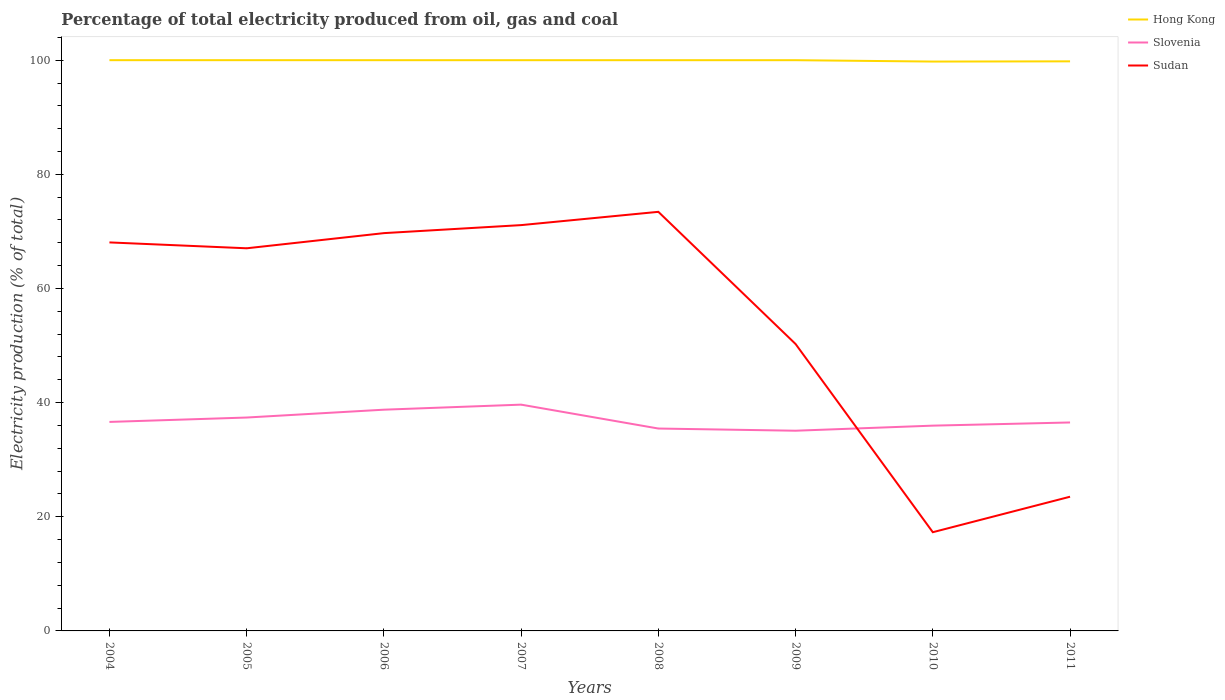Does the line corresponding to Slovenia intersect with the line corresponding to Sudan?
Give a very brief answer. Yes. Is the number of lines equal to the number of legend labels?
Make the answer very short. Yes. Across all years, what is the maximum electricity production in in Hong Kong?
Your response must be concise. 99.76. In which year was the electricity production in in Hong Kong maximum?
Keep it short and to the point. 2010. What is the total electricity production in in Slovenia in the graph?
Make the answer very short. -0.89. What is the difference between the highest and the second highest electricity production in in Sudan?
Offer a terse response. 56.13. How many lines are there?
Your response must be concise. 3. How many years are there in the graph?
Provide a succinct answer. 8. What is the difference between two consecutive major ticks on the Y-axis?
Your answer should be very brief. 20. Are the values on the major ticks of Y-axis written in scientific E-notation?
Make the answer very short. No. Does the graph contain any zero values?
Make the answer very short. No. Where does the legend appear in the graph?
Make the answer very short. Top right. How many legend labels are there?
Keep it short and to the point. 3. How are the legend labels stacked?
Keep it short and to the point. Vertical. What is the title of the graph?
Offer a terse response. Percentage of total electricity produced from oil, gas and coal. What is the label or title of the X-axis?
Give a very brief answer. Years. What is the label or title of the Y-axis?
Provide a succinct answer. Electricity production (% of total). What is the Electricity production (% of total) of Slovenia in 2004?
Keep it short and to the point. 36.62. What is the Electricity production (% of total) in Sudan in 2004?
Ensure brevity in your answer.  68.07. What is the Electricity production (% of total) of Slovenia in 2005?
Your answer should be compact. 37.39. What is the Electricity production (% of total) in Sudan in 2005?
Make the answer very short. 67.04. What is the Electricity production (% of total) of Hong Kong in 2006?
Your response must be concise. 100. What is the Electricity production (% of total) of Slovenia in 2006?
Provide a succinct answer. 38.76. What is the Electricity production (% of total) in Sudan in 2006?
Give a very brief answer. 69.7. What is the Electricity production (% of total) in Hong Kong in 2007?
Give a very brief answer. 100. What is the Electricity production (% of total) in Slovenia in 2007?
Keep it short and to the point. 39.65. What is the Electricity production (% of total) of Sudan in 2007?
Offer a very short reply. 71.1. What is the Electricity production (% of total) of Hong Kong in 2008?
Make the answer very short. 100. What is the Electricity production (% of total) of Slovenia in 2008?
Provide a short and direct response. 35.46. What is the Electricity production (% of total) in Sudan in 2008?
Offer a very short reply. 73.43. What is the Electricity production (% of total) in Hong Kong in 2009?
Provide a short and direct response. 100. What is the Electricity production (% of total) in Slovenia in 2009?
Offer a terse response. 35.08. What is the Electricity production (% of total) in Sudan in 2009?
Keep it short and to the point. 50.27. What is the Electricity production (% of total) in Hong Kong in 2010?
Your answer should be very brief. 99.76. What is the Electricity production (% of total) of Slovenia in 2010?
Offer a very short reply. 35.97. What is the Electricity production (% of total) in Sudan in 2010?
Provide a succinct answer. 17.3. What is the Electricity production (% of total) of Hong Kong in 2011?
Provide a short and direct response. 99.8. What is the Electricity production (% of total) of Slovenia in 2011?
Provide a short and direct response. 36.52. What is the Electricity production (% of total) of Sudan in 2011?
Offer a terse response. 23.51. Across all years, what is the maximum Electricity production (% of total) of Hong Kong?
Offer a very short reply. 100. Across all years, what is the maximum Electricity production (% of total) in Slovenia?
Your response must be concise. 39.65. Across all years, what is the maximum Electricity production (% of total) in Sudan?
Provide a short and direct response. 73.43. Across all years, what is the minimum Electricity production (% of total) of Hong Kong?
Give a very brief answer. 99.76. Across all years, what is the minimum Electricity production (% of total) in Slovenia?
Ensure brevity in your answer.  35.08. Across all years, what is the minimum Electricity production (% of total) in Sudan?
Your response must be concise. 17.3. What is the total Electricity production (% of total) of Hong Kong in the graph?
Offer a very short reply. 799.54. What is the total Electricity production (% of total) in Slovenia in the graph?
Make the answer very short. 295.44. What is the total Electricity production (% of total) of Sudan in the graph?
Offer a very short reply. 440.42. What is the difference between the Electricity production (% of total) of Hong Kong in 2004 and that in 2005?
Your answer should be very brief. 0. What is the difference between the Electricity production (% of total) of Slovenia in 2004 and that in 2005?
Provide a succinct answer. -0.77. What is the difference between the Electricity production (% of total) in Sudan in 2004 and that in 2005?
Provide a short and direct response. 1.03. What is the difference between the Electricity production (% of total) of Hong Kong in 2004 and that in 2006?
Ensure brevity in your answer.  0. What is the difference between the Electricity production (% of total) of Slovenia in 2004 and that in 2006?
Offer a terse response. -2.14. What is the difference between the Electricity production (% of total) of Sudan in 2004 and that in 2006?
Your answer should be very brief. -1.63. What is the difference between the Electricity production (% of total) of Hong Kong in 2004 and that in 2007?
Provide a short and direct response. 0. What is the difference between the Electricity production (% of total) in Slovenia in 2004 and that in 2007?
Your response must be concise. -3.03. What is the difference between the Electricity production (% of total) in Sudan in 2004 and that in 2007?
Your response must be concise. -3.03. What is the difference between the Electricity production (% of total) in Hong Kong in 2004 and that in 2008?
Your answer should be compact. 0. What is the difference between the Electricity production (% of total) in Slovenia in 2004 and that in 2008?
Your answer should be compact. 1.16. What is the difference between the Electricity production (% of total) in Sudan in 2004 and that in 2008?
Provide a succinct answer. -5.36. What is the difference between the Electricity production (% of total) in Hong Kong in 2004 and that in 2009?
Make the answer very short. 0. What is the difference between the Electricity production (% of total) of Slovenia in 2004 and that in 2009?
Keep it short and to the point. 1.54. What is the difference between the Electricity production (% of total) of Sudan in 2004 and that in 2009?
Keep it short and to the point. 17.8. What is the difference between the Electricity production (% of total) in Hong Kong in 2004 and that in 2010?
Your answer should be compact. 0.24. What is the difference between the Electricity production (% of total) in Slovenia in 2004 and that in 2010?
Your answer should be compact. 0.65. What is the difference between the Electricity production (% of total) of Sudan in 2004 and that in 2010?
Your answer should be compact. 50.77. What is the difference between the Electricity production (% of total) of Hong Kong in 2004 and that in 2011?
Your answer should be very brief. 0.2. What is the difference between the Electricity production (% of total) in Slovenia in 2004 and that in 2011?
Make the answer very short. 0.09. What is the difference between the Electricity production (% of total) in Sudan in 2004 and that in 2011?
Your answer should be compact. 44.56. What is the difference between the Electricity production (% of total) of Hong Kong in 2005 and that in 2006?
Keep it short and to the point. 0. What is the difference between the Electricity production (% of total) in Slovenia in 2005 and that in 2006?
Give a very brief answer. -1.37. What is the difference between the Electricity production (% of total) in Sudan in 2005 and that in 2006?
Provide a short and direct response. -2.66. What is the difference between the Electricity production (% of total) of Hong Kong in 2005 and that in 2007?
Offer a terse response. 0. What is the difference between the Electricity production (% of total) of Slovenia in 2005 and that in 2007?
Provide a short and direct response. -2.26. What is the difference between the Electricity production (% of total) of Sudan in 2005 and that in 2007?
Provide a short and direct response. -4.06. What is the difference between the Electricity production (% of total) of Hong Kong in 2005 and that in 2008?
Your answer should be very brief. 0. What is the difference between the Electricity production (% of total) of Slovenia in 2005 and that in 2008?
Make the answer very short. 1.93. What is the difference between the Electricity production (% of total) in Sudan in 2005 and that in 2008?
Keep it short and to the point. -6.39. What is the difference between the Electricity production (% of total) in Hong Kong in 2005 and that in 2009?
Ensure brevity in your answer.  0. What is the difference between the Electricity production (% of total) in Slovenia in 2005 and that in 2009?
Your response must be concise. 2.31. What is the difference between the Electricity production (% of total) in Sudan in 2005 and that in 2009?
Provide a succinct answer. 16.77. What is the difference between the Electricity production (% of total) of Hong Kong in 2005 and that in 2010?
Provide a succinct answer. 0.24. What is the difference between the Electricity production (% of total) in Slovenia in 2005 and that in 2010?
Give a very brief answer. 1.42. What is the difference between the Electricity production (% of total) of Sudan in 2005 and that in 2010?
Ensure brevity in your answer.  49.75. What is the difference between the Electricity production (% of total) of Hong Kong in 2005 and that in 2011?
Ensure brevity in your answer.  0.2. What is the difference between the Electricity production (% of total) in Slovenia in 2005 and that in 2011?
Your response must be concise. 0.86. What is the difference between the Electricity production (% of total) of Sudan in 2005 and that in 2011?
Provide a short and direct response. 43.53. What is the difference between the Electricity production (% of total) in Slovenia in 2006 and that in 2007?
Offer a very short reply. -0.88. What is the difference between the Electricity production (% of total) of Sudan in 2006 and that in 2007?
Provide a short and direct response. -1.4. What is the difference between the Electricity production (% of total) of Slovenia in 2006 and that in 2008?
Ensure brevity in your answer.  3.3. What is the difference between the Electricity production (% of total) in Sudan in 2006 and that in 2008?
Your answer should be compact. -3.73. What is the difference between the Electricity production (% of total) of Hong Kong in 2006 and that in 2009?
Give a very brief answer. -0. What is the difference between the Electricity production (% of total) in Slovenia in 2006 and that in 2009?
Offer a very short reply. 3.69. What is the difference between the Electricity production (% of total) of Sudan in 2006 and that in 2009?
Offer a very short reply. 19.43. What is the difference between the Electricity production (% of total) in Hong Kong in 2006 and that in 2010?
Provide a succinct answer. 0.24. What is the difference between the Electricity production (% of total) in Slovenia in 2006 and that in 2010?
Your answer should be compact. 2.8. What is the difference between the Electricity production (% of total) in Sudan in 2006 and that in 2010?
Give a very brief answer. 52.4. What is the difference between the Electricity production (% of total) of Hong Kong in 2006 and that in 2011?
Your response must be concise. 0.2. What is the difference between the Electricity production (% of total) in Slovenia in 2006 and that in 2011?
Ensure brevity in your answer.  2.24. What is the difference between the Electricity production (% of total) of Sudan in 2006 and that in 2011?
Give a very brief answer. 46.18. What is the difference between the Electricity production (% of total) of Slovenia in 2007 and that in 2008?
Your answer should be compact. 4.19. What is the difference between the Electricity production (% of total) of Sudan in 2007 and that in 2008?
Provide a succinct answer. -2.33. What is the difference between the Electricity production (% of total) of Slovenia in 2007 and that in 2009?
Give a very brief answer. 4.57. What is the difference between the Electricity production (% of total) of Sudan in 2007 and that in 2009?
Provide a short and direct response. 20.83. What is the difference between the Electricity production (% of total) in Hong Kong in 2007 and that in 2010?
Give a very brief answer. 0.24. What is the difference between the Electricity production (% of total) of Slovenia in 2007 and that in 2010?
Ensure brevity in your answer.  3.68. What is the difference between the Electricity production (% of total) in Sudan in 2007 and that in 2010?
Your answer should be compact. 53.81. What is the difference between the Electricity production (% of total) of Hong Kong in 2007 and that in 2011?
Make the answer very short. 0.2. What is the difference between the Electricity production (% of total) in Slovenia in 2007 and that in 2011?
Your response must be concise. 3.12. What is the difference between the Electricity production (% of total) in Sudan in 2007 and that in 2011?
Provide a short and direct response. 47.59. What is the difference between the Electricity production (% of total) of Hong Kong in 2008 and that in 2009?
Ensure brevity in your answer.  -0. What is the difference between the Electricity production (% of total) of Slovenia in 2008 and that in 2009?
Keep it short and to the point. 0.38. What is the difference between the Electricity production (% of total) in Sudan in 2008 and that in 2009?
Make the answer very short. 23.16. What is the difference between the Electricity production (% of total) of Hong Kong in 2008 and that in 2010?
Ensure brevity in your answer.  0.24. What is the difference between the Electricity production (% of total) in Slovenia in 2008 and that in 2010?
Your answer should be compact. -0.51. What is the difference between the Electricity production (% of total) in Sudan in 2008 and that in 2010?
Offer a very short reply. 56.13. What is the difference between the Electricity production (% of total) of Hong Kong in 2008 and that in 2011?
Your answer should be compact. 0.2. What is the difference between the Electricity production (% of total) in Slovenia in 2008 and that in 2011?
Offer a very short reply. -1.06. What is the difference between the Electricity production (% of total) in Sudan in 2008 and that in 2011?
Your answer should be very brief. 49.92. What is the difference between the Electricity production (% of total) of Hong Kong in 2009 and that in 2010?
Give a very brief answer. 0.24. What is the difference between the Electricity production (% of total) in Slovenia in 2009 and that in 2010?
Your response must be concise. -0.89. What is the difference between the Electricity production (% of total) in Sudan in 2009 and that in 2010?
Offer a terse response. 32.97. What is the difference between the Electricity production (% of total) of Hong Kong in 2009 and that in 2011?
Make the answer very short. 0.2. What is the difference between the Electricity production (% of total) of Slovenia in 2009 and that in 2011?
Your answer should be very brief. -1.45. What is the difference between the Electricity production (% of total) in Sudan in 2009 and that in 2011?
Keep it short and to the point. 26.76. What is the difference between the Electricity production (% of total) in Hong Kong in 2010 and that in 2011?
Ensure brevity in your answer.  -0.04. What is the difference between the Electricity production (% of total) of Slovenia in 2010 and that in 2011?
Provide a succinct answer. -0.56. What is the difference between the Electricity production (% of total) in Sudan in 2010 and that in 2011?
Your answer should be compact. -6.22. What is the difference between the Electricity production (% of total) in Hong Kong in 2004 and the Electricity production (% of total) in Slovenia in 2005?
Make the answer very short. 62.61. What is the difference between the Electricity production (% of total) in Hong Kong in 2004 and the Electricity production (% of total) in Sudan in 2005?
Provide a succinct answer. 32.96. What is the difference between the Electricity production (% of total) of Slovenia in 2004 and the Electricity production (% of total) of Sudan in 2005?
Give a very brief answer. -30.42. What is the difference between the Electricity production (% of total) in Hong Kong in 2004 and the Electricity production (% of total) in Slovenia in 2006?
Your answer should be very brief. 61.24. What is the difference between the Electricity production (% of total) in Hong Kong in 2004 and the Electricity production (% of total) in Sudan in 2006?
Your response must be concise. 30.3. What is the difference between the Electricity production (% of total) in Slovenia in 2004 and the Electricity production (% of total) in Sudan in 2006?
Make the answer very short. -33.08. What is the difference between the Electricity production (% of total) of Hong Kong in 2004 and the Electricity production (% of total) of Slovenia in 2007?
Offer a very short reply. 60.35. What is the difference between the Electricity production (% of total) of Hong Kong in 2004 and the Electricity production (% of total) of Sudan in 2007?
Your answer should be compact. 28.9. What is the difference between the Electricity production (% of total) in Slovenia in 2004 and the Electricity production (% of total) in Sudan in 2007?
Your response must be concise. -34.48. What is the difference between the Electricity production (% of total) of Hong Kong in 2004 and the Electricity production (% of total) of Slovenia in 2008?
Provide a short and direct response. 64.54. What is the difference between the Electricity production (% of total) in Hong Kong in 2004 and the Electricity production (% of total) in Sudan in 2008?
Provide a short and direct response. 26.57. What is the difference between the Electricity production (% of total) in Slovenia in 2004 and the Electricity production (% of total) in Sudan in 2008?
Keep it short and to the point. -36.81. What is the difference between the Electricity production (% of total) of Hong Kong in 2004 and the Electricity production (% of total) of Slovenia in 2009?
Ensure brevity in your answer.  64.92. What is the difference between the Electricity production (% of total) of Hong Kong in 2004 and the Electricity production (% of total) of Sudan in 2009?
Keep it short and to the point. 49.73. What is the difference between the Electricity production (% of total) in Slovenia in 2004 and the Electricity production (% of total) in Sudan in 2009?
Your answer should be compact. -13.65. What is the difference between the Electricity production (% of total) in Hong Kong in 2004 and the Electricity production (% of total) in Slovenia in 2010?
Ensure brevity in your answer.  64.03. What is the difference between the Electricity production (% of total) in Hong Kong in 2004 and the Electricity production (% of total) in Sudan in 2010?
Your answer should be compact. 82.7. What is the difference between the Electricity production (% of total) of Slovenia in 2004 and the Electricity production (% of total) of Sudan in 2010?
Offer a very short reply. 19.32. What is the difference between the Electricity production (% of total) of Hong Kong in 2004 and the Electricity production (% of total) of Slovenia in 2011?
Provide a short and direct response. 63.48. What is the difference between the Electricity production (% of total) in Hong Kong in 2004 and the Electricity production (% of total) in Sudan in 2011?
Your response must be concise. 76.49. What is the difference between the Electricity production (% of total) in Slovenia in 2004 and the Electricity production (% of total) in Sudan in 2011?
Your response must be concise. 13.11. What is the difference between the Electricity production (% of total) of Hong Kong in 2005 and the Electricity production (% of total) of Slovenia in 2006?
Offer a terse response. 61.24. What is the difference between the Electricity production (% of total) of Hong Kong in 2005 and the Electricity production (% of total) of Sudan in 2006?
Provide a short and direct response. 30.3. What is the difference between the Electricity production (% of total) of Slovenia in 2005 and the Electricity production (% of total) of Sudan in 2006?
Your answer should be very brief. -32.31. What is the difference between the Electricity production (% of total) of Hong Kong in 2005 and the Electricity production (% of total) of Slovenia in 2007?
Your answer should be compact. 60.35. What is the difference between the Electricity production (% of total) of Hong Kong in 2005 and the Electricity production (% of total) of Sudan in 2007?
Provide a short and direct response. 28.9. What is the difference between the Electricity production (% of total) of Slovenia in 2005 and the Electricity production (% of total) of Sudan in 2007?
Give a very brief answer. -33.71. What is the difference between the Electricity production (% of total) in Hong Kong in 2005 and the Electricity production (% of total) in Slovenia in 2008?
Give a very brief answer. 64.54. What is the difference between the Electricity production (% of total) in Hong Kong in 2005 and the Electricity production (% of total) in Sudan in 2008?
Provide a succinct answer. 26.57. What is the difference between the Electricity production (% of total) of Slovenia in 2005 and the Electricity production (% of total) of Sudan in 2008?
Your answer should be very brief. -36.04. What is the difference between the Electricity production (% of total) of Hong Kong in 2005 and the Electricity production (% of total) of Slovenia in 2009?
Provide a short and direct response. 64.92. What is the difference between the Electricity production (% of total) of Hong Kong in 2005 and the Electricity production (% of total) of Sudan in 2009?
Ensure brevity in your answer.  49.73. What is the difference between the Electricity production (% of total) in Slovenia in 2005 and the Electricity production (% of total) in Sudan in 2009?
Make the answer very short. -12.88. What is the difference between the Electricity production (% of total) of Hong Kong in 2005 and the Electricity production (% of total) of Slovenia in 2010?
Provide a succinct answer. 64.03. What is the difference between the Electricity production (% of total) of Hong Kong in 2005 and the Electricity production (% of total) of Sudan in 2010?
Your answer should be very brief. 82.7. What is the difference between the Electricity production (% of total) of Slovenia in 2005 and the Electricity production (% of total) of Sudan in 2010?
Your response must be concise. 20.09. What is the difference between the Electricity production (% of total) in Hong Kong in 2005 and the Electricity production (% of total) in Slovenia in 2011?
Give a very brief answer. 63.48. What is the difference between the Electricity production (% of total) in Hong Kong in 2005 and the Electricity production (% of total) in Sudan in 2011?
Provide a succinct answer. 76.49. What is the difference between the Electricity production (% of total) in Slovenia in 2005 and the Electricity production (% of total) in Sudan in 2011?
Offer a very short reply. 13.88. What is the difference between the Electricity production (% of total) in Hong Kong in 2006 and the Electricity production (% of total) in Slovenia in 2007?
Ensure brevity in your answer.  60.35. What is the difference between the Electricity production (% of total) of Hong Kong in 2006 and the Electricity production (% of total) of Sudan in 2007?
Offer a very short reply. 28.9. What is the difference between the Electricity production (% of total) in Slovenia in 2006 and the Electricity production (% of total) in Sudan in 2007?
Make the answer very short. -32.34. What is the difference between the Electricity production (% of total) in Hong Kong in 2006 and the Electricity production (% of total) in Slovenia in 2008?
Ensure brevity in your answer.  64.54. What is the difference between the Electricity production (% of total) of Hong Kong in 2006 and the Electricity production (% of total) of Sudan in 2008?
Provide a succinct answer. 26.57. What is the difference between the Electricity production (% of total) in Slovenia in 2006 and the Electricity production (% of total) in Sudan in 2008?
Offer a very short reply. -34.67. What is the difference between the Electricity production (% of total) of Hong Kong in 2006 and the Electricity production (% of total) of Slovenia in 2009?
Keep it short and to the point. 64.92. What is the difference between the Electricity production (% of total) of Hong Kong in 2006 and the Electricity production (% of total) of Sudan in 2009?
Keep it short and to the point. 49.73. What is the difference between the Electricity production (% of total) in Slovenia in 2006 and the Electricity production (% of total) in Sudan in 2009?
Ensure brevity in your answer.  -11.51. What is the difference between the Electricity production (% of total) in Hong Kong in 2006 and the Electricity production (% of total) in Slovenia in 2010?
Give a very brief answer. 64.03. What is the difference between the Electricity production (% of total) of Hong Kong in 2006 and the Electricity production (% of total) of Sudan in 2010?
Offer a very short reply. 82.7. What is the difference between the Electricity production (% of total) in Slovenia in 2006 and the Electricity production (% of total) in Sudan in 2010?
Give a very brief answer. 21.47. What is the difference between the Electricity production (% of total) of Hong Kong in 2006 and the Electricity production (% of total) of Slovenia in 2011?
Give a very brief answer. 63.47. What is the difference between the Electricity production (% of total) in Hong Kong in 2006 and the Electricity production (% of total) in Sudan in 2011?
Provide a short and direct response. 76.48. What is the difference between the Electricity production (% of total) of Slovenia in 2006 and the Electricity production (% of total) of Sudan in 2011?
Your answer should be compact. 15.25. What is the difference between the Electricity production (% of total) of Hong Kong in 2007 and the Electricity production (% of total) of Slovenia in 2008?
Keep it short and to the point. 64.54. What is the difference between the Electricity production (% of total) in Hong Kong in 2007 and the Electricity production (% of total) in Sudan in 2008?
Offer a terse response. 26.57. What is the difference between the Electricity production (% of total) of Slovenia in 2007 and the Electricity production (% of total) of Sudan in 2008?
Offer a terse response. -33.78. What is the difference between the Electricity production (% of total) in Hong Kong in 2007 and the Electricity production (% of total) in Slovenia in 2009?
Make the answer very short. 64.92. What is the difference between the Electricity production (% of total) in Hong Kong in 2007 and the Electricity production (% of total) in Sudan in 2009?
Your answer should be compact. 49.73. What is the difference between the Electricity production (% of total) of Slovenia in 2007 and the Electricity production (% of total) of Sudan in 2009?
Your response must be concise. -10.62. What is the difference between the Electricity production (% of total) in Hong Kong in 2007 and the Electricity production (% of total) in Slovenia in 2010?
Provide a short and direct response. 64.03. What is the difference between the Electricity production (% of total) in Hong Kong in 2007 and the Electricity production (% of total) in Sudan in 2010?
Offer a very short reply. 82.7. What is the difference between the Electricity production (% of total) of Slovenia in 2007 and the Electricity production (% of total) of Sudan in 2010?
Give a very brief answer. 22.35. What is the difference between the Electricity production (% of total) in Hong Kong in 2007 and the Electricity production (% of total) in Slovenia in 2011?
Give a very brief answer. 63.47. What is the difference between the Electricity production (% of total) of Hong Kong in 2007 and the Electricity production (% of total) of Sudan in 2011?
Offer a terse response. 76.48. What is the difference between the Electricity production (% of total) in Slovenia in 2007 and the Electricity production (% of total) in Sudan in 2011?
Ensure brevity in your answer.  16.13. What is the difference between the Electricity production (% of total) in Hong Kong in 2008 and the Electricity production (% of total) in Slovenia in 2009?
Your answer should be compact. 64.92. What is the difference between the Electricity production (% of total) of Hong Kong in 2008 and the Electricity production (% of total) of Sudan in 2009?
Your answer should be compact. 49.73. What is the difference between the Electricity production (% of total) of Slovenia in 2008 and the Electricity production (% of total) of Sudan in 2009?
Your answer should be very brief. -14.81. What is the difference between the Electricity production (% of total) in Hong Kong in 2008 and the Electricity production (% of total) in Slovenia in 2010?
Ensure brevity in your answer.  64.03. What is the difference between the Electricity production (% of total) in Hong Kong in 2008 and the Electricity production (% of total) in Sudan in 2010?
Provide a short and direct response. 82.7. What is the difference between the Electricity production (% of total) of Slovenia in 2008 and the Electricity production (% of total) of Sudan in 2010?
Ensure brevity in your answer.  18.16. What is the difference between the Electricity production (% of total) of Hong Kong in 2008 and the Electricity production (% of total) of Slovenia in 2011?
Ensure brevity in your answer.  63.47. What is the difference between the Electricity production (% of total) of Hong Kong in 2008 and the Electricity production (% of total) of Sudan in 2011?
Your answer should be very brief. 76.48. What is the difference between the Electricity production (% of total) in Slovenia in 2008 and the Electricity production (% of total) in Sudan in 2011?
Provide a short and direct response. 11.95. What is the difference between the Electricity production (% of total) of Hong Kong in 2009 and the Electricity production (% of total) of Slovenia in 2010?
Your response must be concise. 64.03. What is the difference between the Electricity production (% of total) of Hong Kong in 2009 and the Electricity production (% of total) of Sudan in 2010?
Your response must be concise. 82.7. What is the difference between the Electricity production (% of total) of Slovenia in 2009 and the Electricity production (% of total) of Sudan in 2010?
Your answer should be very brief. 17.78. What is the difference between the Electricity production (% of total) of Hong Kong in 2009 and the Electricity production (% of total) of Slovenia in 2011?
Your response must be concise. 63.47. What is the difference between the Electricity production (% of total) of Hong Kong in 2009 and the Electricity production (% of total) of Sudan in 2011?
Give a very brief answer. 76.48. What is the difference between the Electricity production (% of total) of Slovenia in 2009 and the Electricity production (% of total) of Sudan in 2011?
Keep it short and to the point. 11.56. What is the difference between the Electricity production (% of total) of Hong Kong in 2010 and the Electricity production (% of total) of Slovenia in 2011?
Provide a succinct answer. 63.23. What is the difference between the Electricity production (% of total) in Hong Kong in 2010 and the Electricity production (% of total) in Sudan in 2011?
Provide a succinct answer. 76.25. What is the difference between the Electricity production (% of total) in Slovenia in 2010 and the Electricity production (% of total) in Sudan in 2011?
Offer a very short reply. 12.45. What is the average Electricity production (% of total) in Hong Kong per year?
Your answer should be very brief. 99.94. What is the average Electricity production (% of total) of Slovenia per year?
Ensure brevity in your answer.  36.93. What is the average Electricity production (% of total) of Sudan per year?
Give a very brief answer. 55.05. In the year 2004, what is the difference between the Electricity production (% of total) of Hong Kong and Electricity production (% of total) of Slovenia?
Your answer should be very brief. 63.38. In the year 2004, what is the difference between the Electricity production (% of total) in Hong Kong and Electricity production (% of total) in Sudan?
Keep it short and to the point. 31.93. In the year 2004, what is the difference between the Electricity production (% of total) in Slovenia and Electricity production (% of total) in Sudan?
Your response must be concise. -31.45. In the year 2005, what is the difference between the Electricity production (% of total) in Hong Kong and Electricity production (% of total) in Slovenia?
Provide a succinct answer. 62.61. In the year 2005, what is the difference between the Electricity production (% of total) in Hong Kong and Electricity production (% of total) in Sudan?
Provide a succinct answer. 32.96. In the year 2005, what is the difference between the Electricity production (% of total) of Slovenia and Electricity production (% of total) of Sudan?
Offer a terse response. -29.65. In the year 2006, what is the difference between the Electricity production (% of total) in Hong Kong and Electricity production (% of total) in Slovenia?
Offer a very short reply. 61.23. In the year 2006, what is the difference between the Electricity production (% of total) in Hong Kong and Electricity production (% of total) in Sudan?
Give a very brief answer. 30.3. In the year 2006, what is the difference between the Electricity production (% of total) in Slovenia and Electricity production (% of total) in Sudan?
Your answer should be very brief. -30.93. In the year 2007, what is the difference between the Electricity production (% of total) of Hong Kong and Electricity production (% of total) of Slovenia?
Keep it short and to the point. 60.35. In the year 2007, what is the difference between the Electricity production (% of total) of Hong Kong and Electricity production (% of total) of Sudan?
Your response must be concise. 28.9. In the year 2007, what is the difference between the Electricity production (% of total) of Slovenia and Electricity production (% of total) of Sudan?
Provide a succinct answer. -31.45. In the year 2008, what is the difference between the Electricity production (% of total) in Hong Kong and Electricity production (% of total) in Slovenia?
Your answer should be very brief. 64.54. In the year 2008, what is the difference between the Electricity production (% of total) in Hong Kong and Electricity production (% of total) in Sudan?
Ensure brevity in your answer.  26.57. In the year 2008, what is the difference between the Electricity production (% of total) of Slovenia and Electricity production (% of total) of Sudan?
Provide a short and direct response. -37.97. In the year 2009, what is the difference between the Electricity production (% of total) in Hong Kong and Electricity production (% of total) in Slovenia?
Offer a very short reply. 64.92. In the year 2009, what is the difference between the Electricity production (% of total) of Hong Kong and Electricity production (% of total) of Sudan?
Offer a terse response. 49.73. In the year 2009, what is the difference between the Electricity production (% of total) of Slovenia and Electricity production (% of total) of Sudan?
Offer a terse response. -15.19. In the year 2010, what is the difference between the Electricity production (% of total) of Hong Kong and Electricity production (% of total) of Slovenia?
Provide a short and direct response. 63.79. In the year 2010, what is the difference between the Electricity production (% of total) in Hong Kong and Electricity production (% of total) in Sudan?
Keep it short and to the point. 82.46. In the year 2010, what is the difference between the Electricity production (% of total) of Slovenia and Electricity production (% of total) of Sudan?
Provide a short and direct response. 18.67. In the year 2011, what is the difference between the Electricity production (% of total) in Hong Kong and Electricity production (% of total) in Slovenia?
Keep it short and to the point. 63.27. In the year 2011, what is the difference between the Electricity production (% of total) of Hong Kong and Electricity production (% of total) of Sudan?
Offer a very short reply. 76.28. In the year 2011, what is the difference between the Electricity production (% of total) in Slovenia and Electricity production (% of total) in Sudan?
Your answer should be very brief. 13.01. What is the ratio of the Electricity production (% of total) in Hong Kong in 2004 to that in 2005?
Offer a very short reply. 1. What is the ratio of the Electricity production (% of total) of Slovenia in 2004 to that in 2005?
Your answer should be compact. 0.98. What is the ratio of the Electricity production (% of total) in Sudan in 2004 to that in 2005?
Your response must be concise. 1.02. What is the ratio of the Electricity production (% of total) of Slovenia in 2004 to that in 2006?
Make the answer very short. 0.94. What is the ratio of the Electricity production (% of total) of Sudan in 2004 to that in 2006?
Offer a very short reply. 0.98. What is the ratio of the Electricity production (% of total) in Hong Kong in 2004 to that in 2007?
Provide a short and direct response. 1. What is the ratio of the Electricity production (% of total) in Slovenia in 2004 to that in 2007?
Provide a short and direct response. 0.92. What is the ratio of the Electricity production (% of total) in Sudan in 2004 to that in 2007?
Provide a short and direct response. 0.96. What is the ratio of the Electricity production (% of total) in Hong Kong in 2004 to that in 2008?
Your answer should be very brief. 1. What is the ratio of the Electricity production (% of total) of Slovenia in 2004 to that in 2008?
Provide a succinct answer. 1.03. What is the ratio of the Electricity production (% of total) of Sudan in 2004 to that in 2008?
Offer a very short reply. 0.93. What is the ratio of the Electricity production (% of total) of Hong Kong in 2004 to that in 2009?
Provide a succinct answer. 1. What is the ratio of the Electricity production (% of total) of Slovenia in 2004 to that in 2009?
Your response must be concise. 1.04. What is the ratio of the Electricity production (% of total) in Sudan in 2004 to that in 2009?
Provide a short and direct response. 1.35. What is the ratio of the Electricity production (% of total) in Hong Kong in 2004 to that in 2010?
Make the answer very short. 1. What is the ratio of the Electricity production (% of total) in Slovenia in 2004 to that in 2010?
Make the answer very short. 1.02. What is the ratio of the Electricity production (% of total) of Sudan in 2004 to that in 2010?
Offer a very short reply. 3.94. What is the ratio of the Electricity production (% of total) of Hong Kong in 2004 to that in 2011?
Your response must be concise. 1. What is the ratio of the Electricity production (% of total) in Slovenia in 2004 to that in 2011?
Give a very brief answer. 1. What is the ratio of the Electricity production (% of total) of Sudan in 2004 to that in 2011?
Offer a terse response. 2.9. What is the ratio of the Electricity production (% of total) in Slovenia in 2005 to that in 2006?
Your answer should be very brief. 0.96. What is the ratio of the Electricity production (% of total) in Sudan in 2005 to that in 2006?
Make the answer very short. 0.96. What is the ratio of the Electricity production (% of total) of Hong Kong in 2005 to that in 2007?
Provide a short and direct response. 1. What is the ratio of the Electricity production (% of total) in Slovenia in 2005 to that in 2007?
Keep it short and to the point. 0.94. What is the ratio of the Electricity production (% of total) of Sudan in 2005 to that in 2007?
Your response must be concise. 0.94. What is the ratio of the Electricity production (% of total) of Hong Kong in 2005 to that in 2008?
Keep it short and to the point. 1. What is the ratio of the Electricity production (% of total) of Slovenia in 2005 to that in 2008?
Your response must be concise. 1.05. What is the ratio of the Electricity production (% of total) of Hong Kong in 2005 to that in 2009?
Give a very brief answer. 1. What is the ratio of the Electricity production (% of total) of Slovenia in 2005 to that in 2009?
Offer a terse response. 1.07. What is the ratio of the Electricity production (% of total) of Sudan in 2005 to that in 2009?
Ensure brevity in your answer.  1.33. What is the ratio of the Electricity production (% of total) in Hong Kong in 2005 to that in 2010?
Offer a terse response. 1. What is the ratio of the Electricity production (% of total) in Slovenia in 2005 to that in 2010?
Make the answer very short. 1.04. What is the ratio of the Electricity production (% of total) of Sudan in 2005 to that in 2010?
Provide a short and direct response. 3.88. What is the ratio of the Electricity production (% of total) in Slovenia in 2005 to that in 2011?
Give a very brief answer. 1.02. What is the ratio of the Electricity production (% of total) in Sudan in 2005 to that in 2011?
Make the answer very short. 2.85. What is the ratio of the Electricity production (% of total) in Hong Kong in 2006 to that in 2007?
Your response must be concise. 1. What is the ratio of the Electricity production (% of total) in Slovenia in 2006 to that in 2007?
Provide a short and direct response. 0.98. What is the ratio of the Electricity production (% of total) in Sudan in 2006 to that in 2007?
Make the answer very short. 0.98. What is the ratio of the Electricity production (% of total) in Hong Kong in 2006 to that in 2008?
Ensure brevity in your answer.  1. What is the ratio of the Electricity production (% of total) of Slovenia in 2006 to that in 2008?
Your answer should be very brief. 1.09. What is the ratio of the Electricity production (% of total) of Sudan in 2006 to that in 2008?
Make the answer very short. 0.95. What is the ratio of the Electricity production (% of total) in Hong Kong in 2006 to that in 2009?
Your answer should be compact. 1. What is the ratio of the Electricity production (% of total) in Slovenia in 2006 to that in 2009?
Ensure brevity in your answer.  1.11. What is the ratio of the Electricity production (% of total) in Sudan in 2006 to that in 2009?
Provide a succinct answer. 1.39. What is the ratio of the Electricity production (% of total) of Hong Kong in 2006 to that in 2010?
Keep it short and to the point. 1. What is the ratio of the Electricity production (% of total) in Slovenia in 2006 to that in 2010?
Your answer should be compact. 1.08. What is the ratio of the Electricity production (% of total) of Sudan in 2006 to that in 2010?
Give a very brief answer. 4.03. What is the ratio of the Electricity production (% of total) of Hong Kong in 2006 to that in 2011?
Your answer should be very brief. 1. What is the ratio of the Electricity production (% of total) of Slovenia in 2006 to that in 2011?
Provide a short and direct response. 1.06. What is the ratio of the Electricity production (% of total) in Sudan in 2006 to that in 2011?
Your response must be concise. 2.96. What is the ratio of the Electricity production (% of total) in Slovenia in 2007 to that in 2008?
Give a very brief answer. 1.12. What is the ratio of the Electricity production (% of total) of Sudan in 2007 to that in 2008?
Keep it short and to the point. 0.97. What is the ratio of the Electricity production (% of total) in Slovenia in 2007 to that in 2009?
Offer a terse response. 1.13. What is the ratio of the Electricity production (% of total) of Sudan in 2007 to that in 2009?
Keep it short and to the point. 1.41. What is the ratio of the Electricity production (% of total) of Hong Kong in 2007 to that in 2010?
Make the answer very short. 1. What is the ratio of the Electricity production (% of total) of Slovenia in 2007 to that in 2010?
Make the answer very short. 1.1. What is the ratio of the Electricity production (% of total) in Sudan in 2007 to that in 2010?
Offer a very short reply. 4.11. What is the ratio of the Electricity production (% of total) in Slovenia in 2007 to that in 2011?
Provide a succinct answer. 1.09. What is the ratio of the Electricity production (% of total) in Sudan in 2007 to that in 2011?
Provide a succinct answer. 3.02. What is the ratio of the Electricity production (% of total) in Slovenia in 2008 to that in 2009?
Ensure brevity in your answer.  1.01. What is the ratio of the Electricity production (% of total) in Sudan in 2008 to that in 2009?
Keep it short and to the point. 1.46. What is the ratio of the Electricity production (% of total) in Hong Kong in 2008 to that in 2010?
Provide a succinct answer. 1. What is the ratio of the Electricity production (% of total) of Slovenia in 2008 to that in 2010?
Your answer should be compact. 0.99. What is the ratio of the Electricity production (% of total) of Sudan in 2008 to that in 2010?
Keep it short and to the point. 4.25. What is the ratio of the Electricity production (% of total) of Hong Kong in 2008 to that in 2011?
Your answer should be very brief. 1. What is the ratio of the Electricity production (% of total) of Slovenia in 2008 to that in 2011?
Offer a terse response. 0.97. What is the ratio of the Electricity production (% of total) of Sudan in 2008 to that in 2011?
Offer a very short reply. 3.12. What is the ratio of the Electricity production (% of total) in Slovenia in 2009 to that in 2010?
Make the answer very short. 0.98. What is the ratio of the Electricity production (% of total) in Sudan in 2009 to that in 2010?
Offer a very short reply. 2.91. What is the ratio of the Electricity production (% of total) of Hong Kong in 2009 to that in 2011?
Offer a terse response. 1. What is the ratio of the Electricity production (% of total) of Slovenia in 2009 to that in 2011?
Your answer should be compact. 0.96. What is the ratio of the Electricity production (% of total) in Sudan in 2009 to that in 2011?
Keep it short and to the point. 2.14. What is the ratio of the Electricity production (% of total) of Hong Kong in 2010 to that in 2011?
Offer a very short reply. 1. What is the ratio of the Electricity production (% of total) in Sudan in 2010 to that in 2011?
Make the answer very short. 0.74. What is the difference between the highest and the second highest Electricity production (% of total) in Slovenia?
Make the answer very short. 0.88. What is the difference between the highest and the second highest Electricity production (% of total) in Sudan?
Provide a succinct answer. 2.33. What is the difference between the highest and the lowest Electricity production (% of total) of Hong Kong?
Ensure brevity in your answer.  0.24. What is the difference between the highest and the lowest Electricity production (% of total) of Slovenia?
Provide a short and direct response. 4.57. What is the difference between the highest and the lowest Electricity production (% of total) in Sudan?
Ensure brevity in your answer.  56.13. 